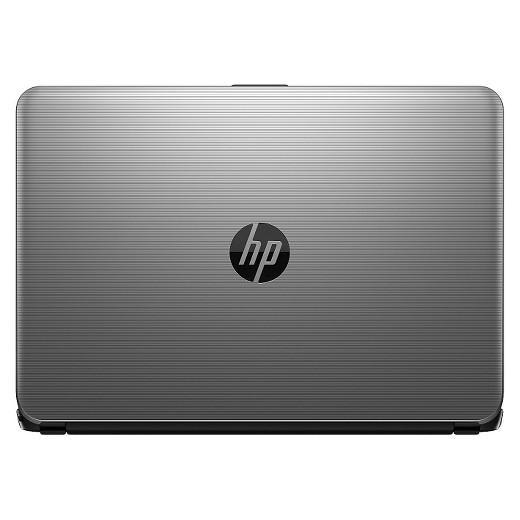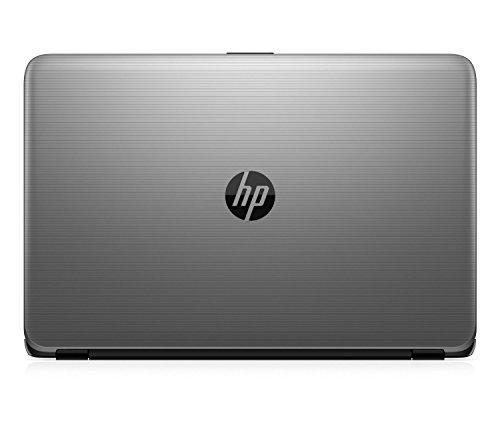The first image is the image on the left, the second image is the image on the right. Given the left and right images, does the statement "There is an open laptop with a white screen displayed that features a blue circular logo" hold true? Answer yes or no. No. The first image is the image on the left, the second image is the image on the right. For the images displayed, is the sentence "A laptop is turned so the screen is visible, and another laptop is turned so the back of the screen is visible." factually correct? Answer yes or no. No. 